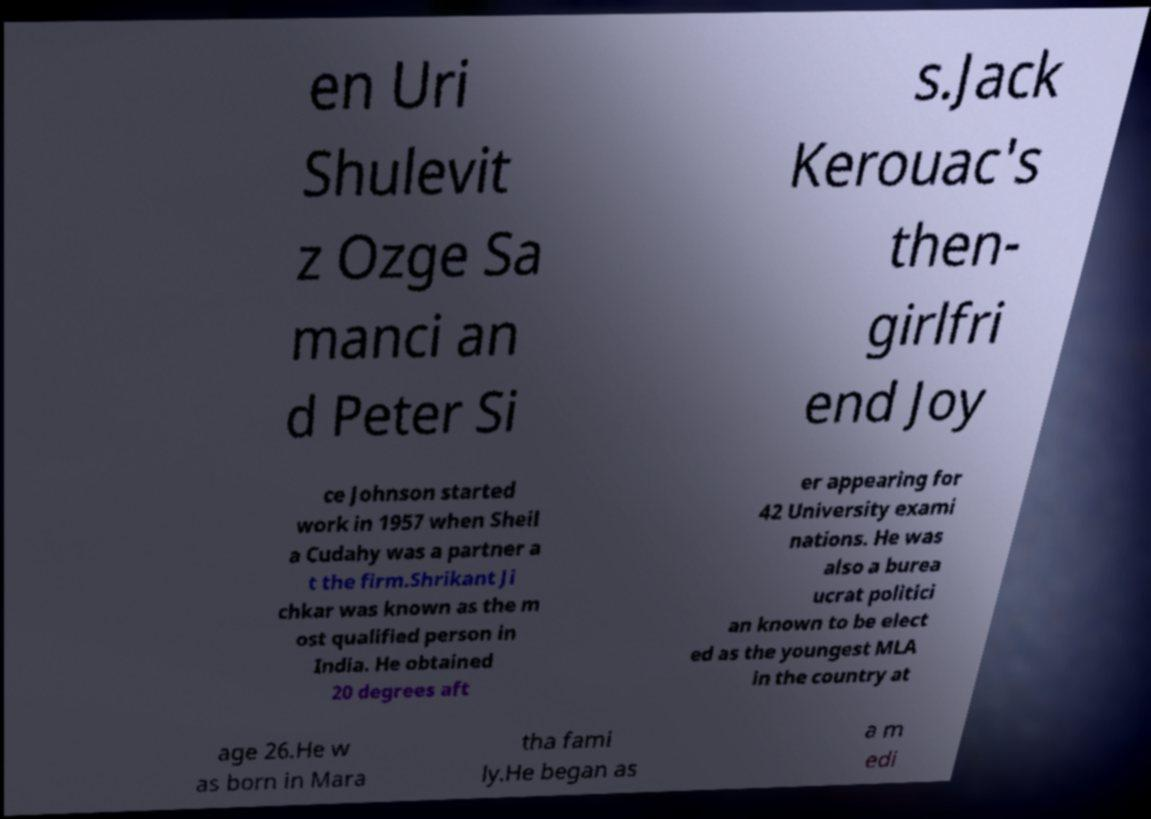There's text embedded in this image that I need extracted. Can you transcribe it verbatim? en Uri Shulevit z Ozge Sa manci an d Peter Si s.Jack Kerouac's then- girlfri end Joy ce Johnson started work in 1957 when Sheil a Cudahy was a partner a t the firm.Shrikant Ji chkar was known as the m ost qualified person in India. He obtained 20 degrees aft er appearing for 42 University exami nations. He was also a burea ucrat politici an known to be elect ed as the youngest MLA in the country at age 26.He w as born in Mara tha fami ly.He began as a m edi 